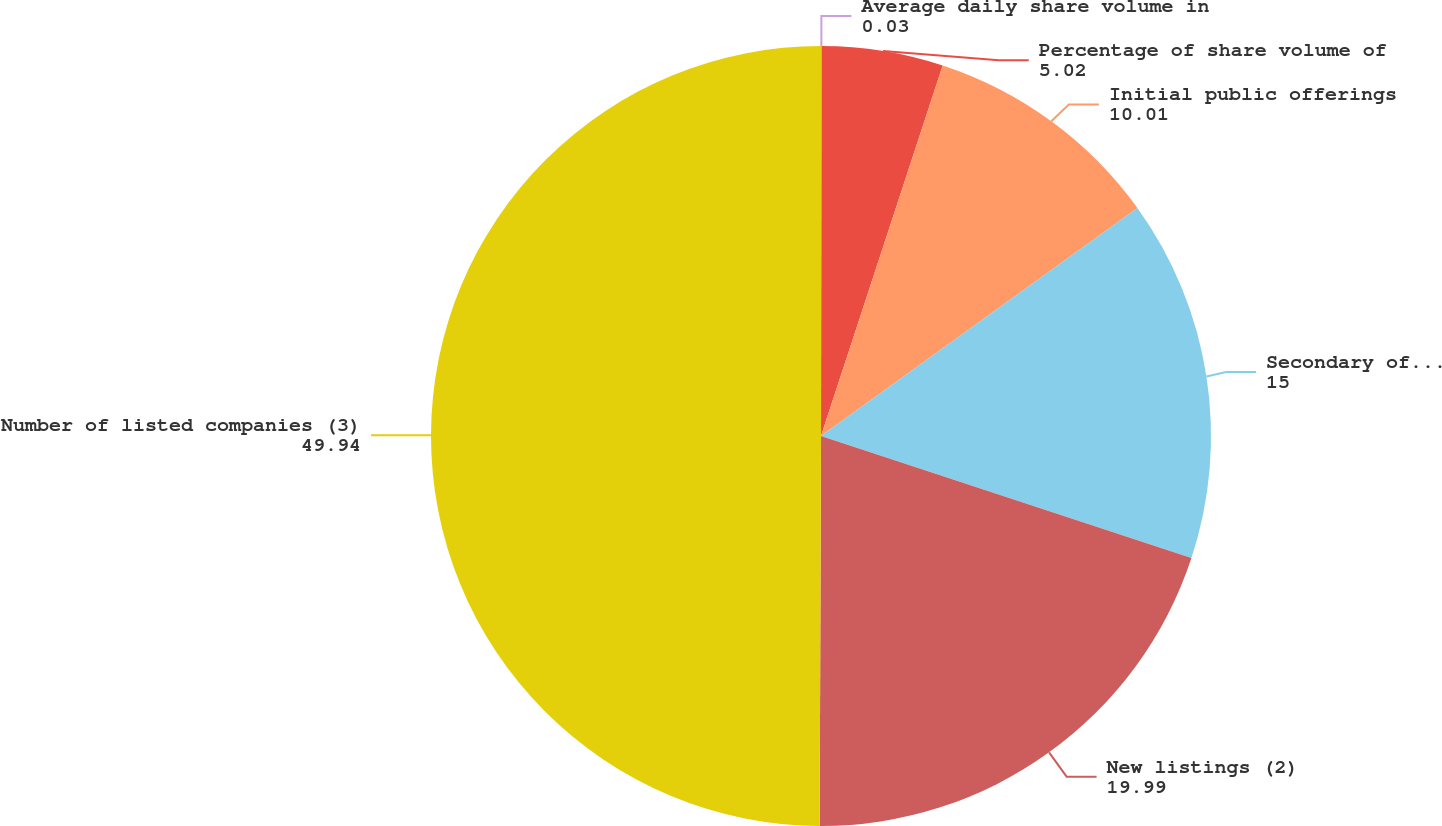Convert chart. <chart><loc_0><loc_0><loc_500><loc_500><pie_chart><fcel>Average daily share volume in<fcel>Percentage of share volume of<fcel>Initial public offerings<fcel>Secondary offerings<fcel>New listings (2)<fcel>Number of listed companies (3)<nl><fcel>0.03%<fcel>5.02%<fcel>10.01%<fcel>15.0%<fcel>19.99%<fcel>49.94%<nl></chart> 